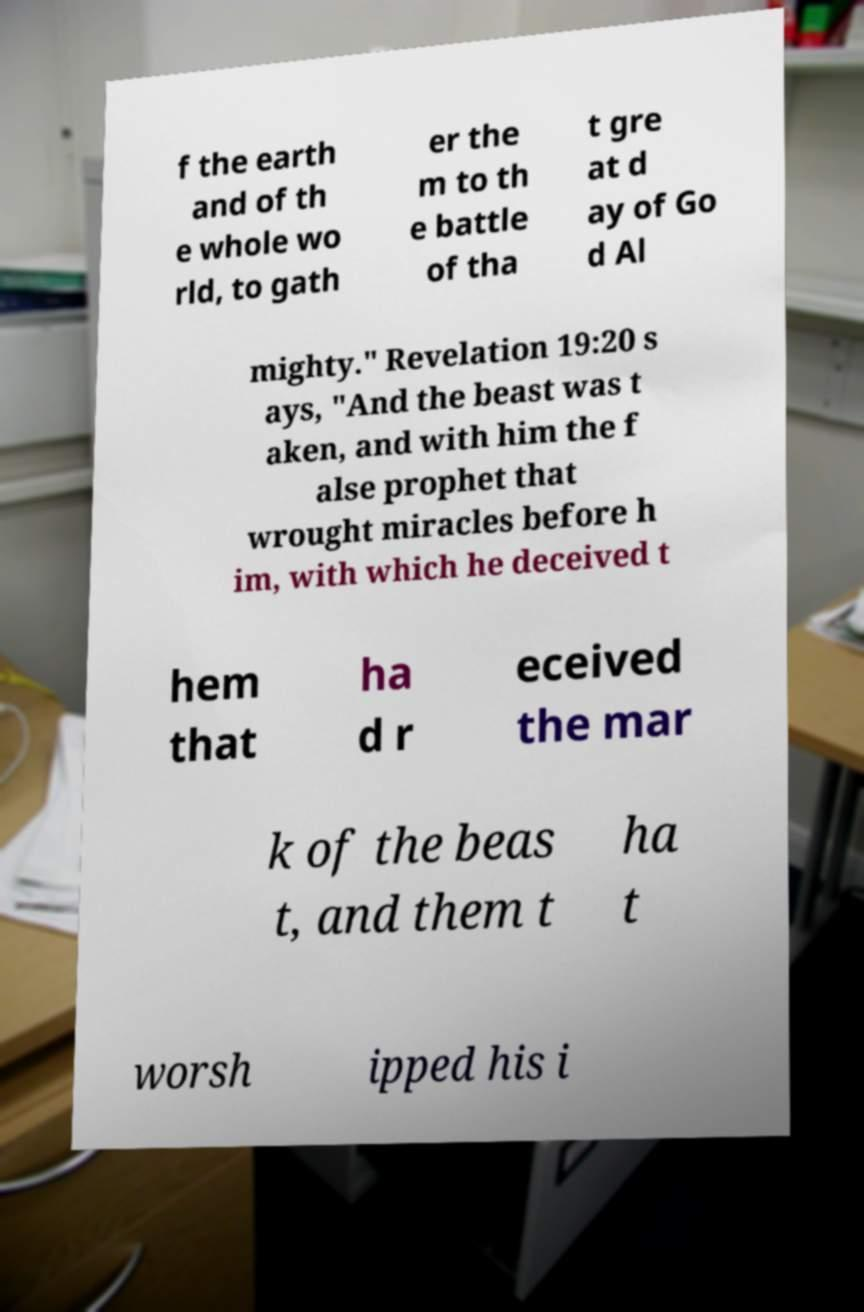Please read and relay the text visible in this image. What does it say? f the earth and of th e whole wo rld, to gath er the m to th e battle of tha t gre at d ay of Go d Al mighty." Revelation 19:20 s ays, "And the beast was t aken, and with him the f alse prophet that wrought miracles before h im, with which he deceived t hem that ha d r eceived the mar k of the beas t, and them t ha t worsh ipped his i 